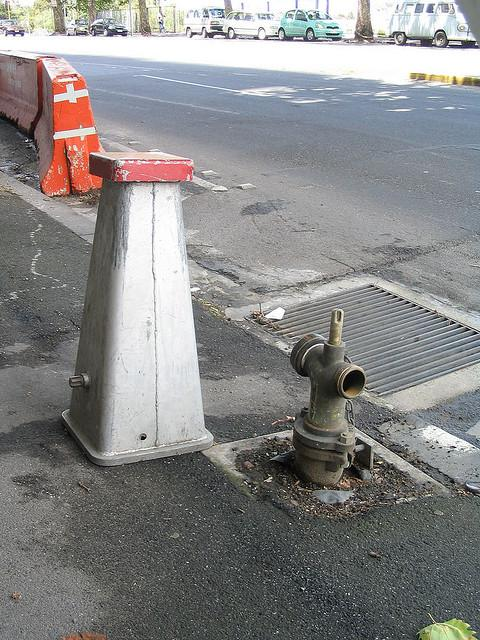What is on the floor? Please explain your reasoning. grate. A sewer grate is on the ground. 